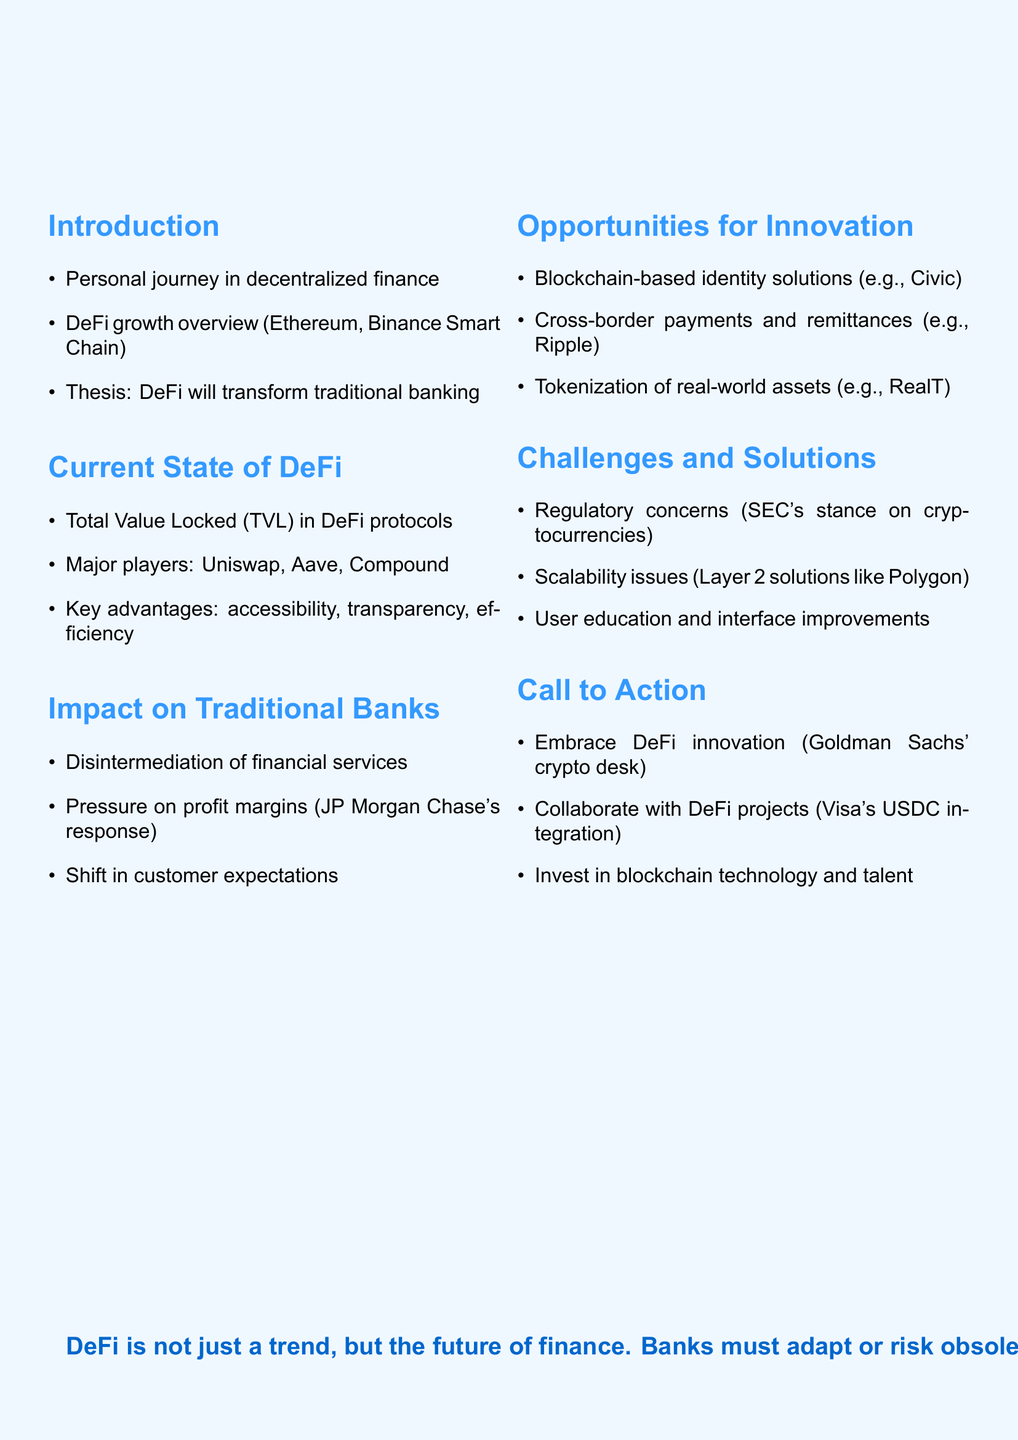What is the title of the keynote speech? The title is the primary heading given at the beginning of the document, which summarizes the topic.
Answer: The Future of Decentralized Banking: Reshaping the Financial Landscape Who are the major players in the current state of DeFi? This question seeks specific names listed under the section about the current state of DeFi in the document.
Answer: Uniswap, Aave, Compound What does DeFi stand for? This abbreviation is introduced early in the document and represents the core concept discussed.
Answer: Decentralized Finance What is the Total Value Locked in DeFi protocols? This question requests a specific metric related to the current state of DeFi’s health, mentioned as a key point.
Answer: [Not provided in the document] What regulatory challenge is mentioned in the challenges and solutions section? The section outlines specific challenges faced by decentralized finance, including regulatory concerns.
Answer: Regulatory concerns What example of a blockchain-based identity solution is provided? This question looks for a specific instance mentioned under opportunities for innovation related to identity solutions.
Answer: Civic What is one way traditional banks are responding to DeFi? This question addresses how traditional financial institutions are reacting to the rise of decentralized banking based on pressure on their profit margins.
Answer: JP Morgan Chase's response What is the call to action for financial institutions? The call to action summarizes the recommended steps traditional banks should consider in adapting to DeFi.
Answer: Embrace DeFi innovation What is the conclusion stated in the document? The conclusion encapsulates the overarching view presented in the document regarding the future of finance and the role of banks.
Answer: DeFi is not just a trend, but the future of finance. Banks must adapt or risk obsolescence 